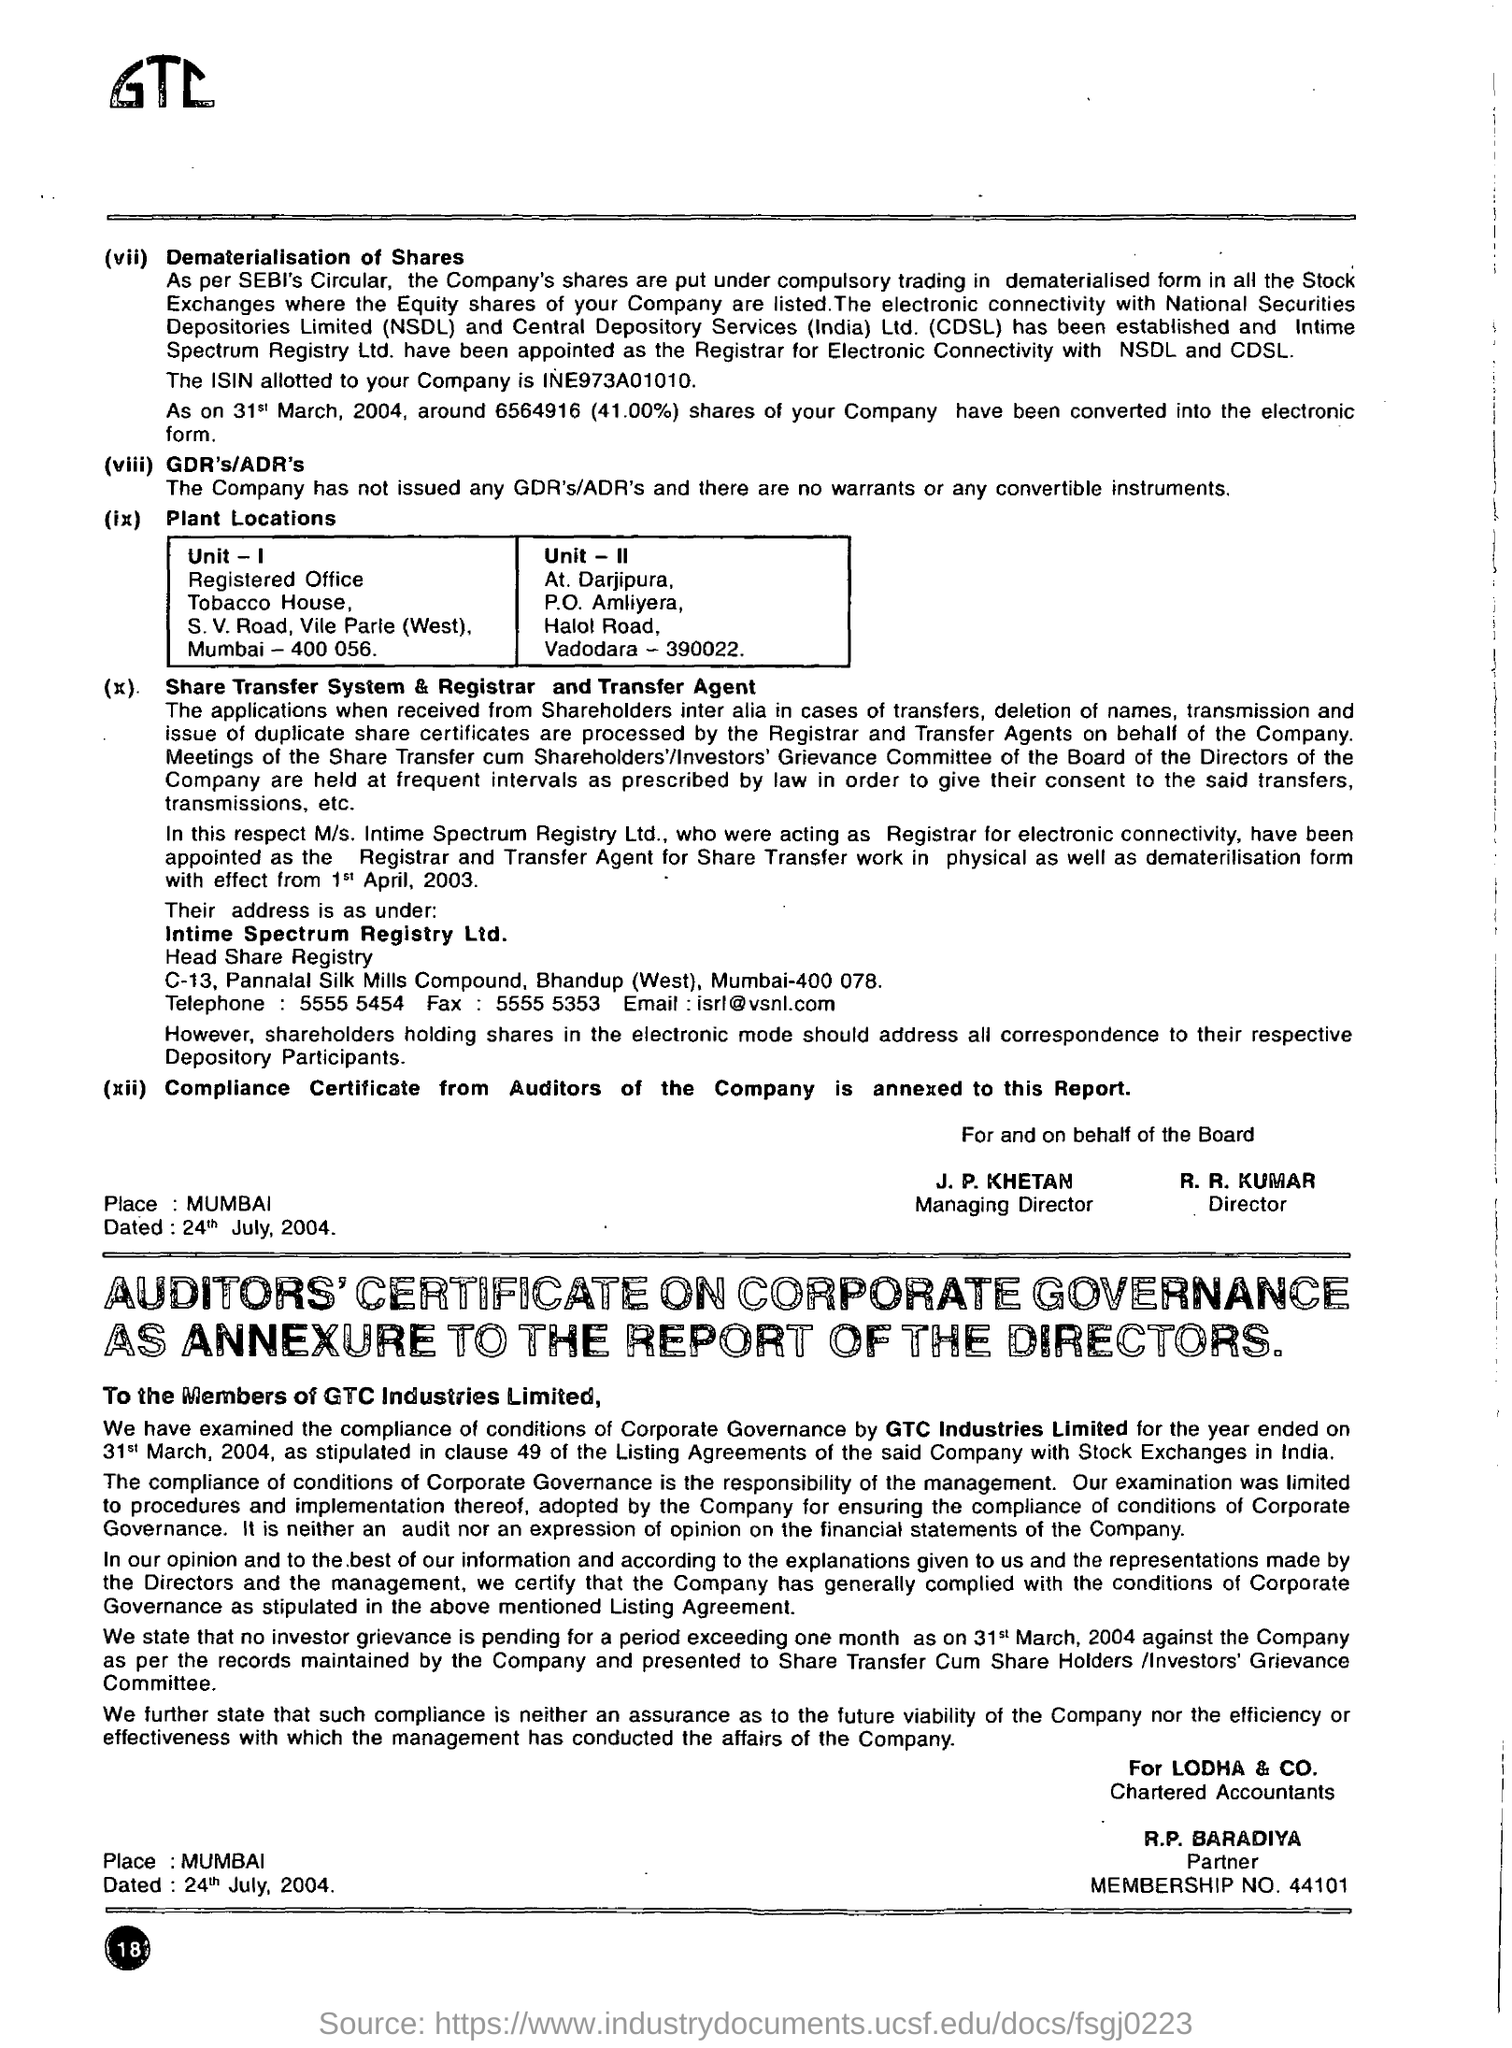What are the specific responsibilities of the share transfer and registrar agent mentioned? The share transfer and registrar agent, Intime Spectrum Registry Ltd., is responsible for handling the transfer of shares, dealing with deletions of names, and ensuring accurate transmission and issue of duplicate share certificates. They act on behalf of the company to facilitate smooth transactions and maintain shareholder records, playing a crucial role in shareholder relations. 